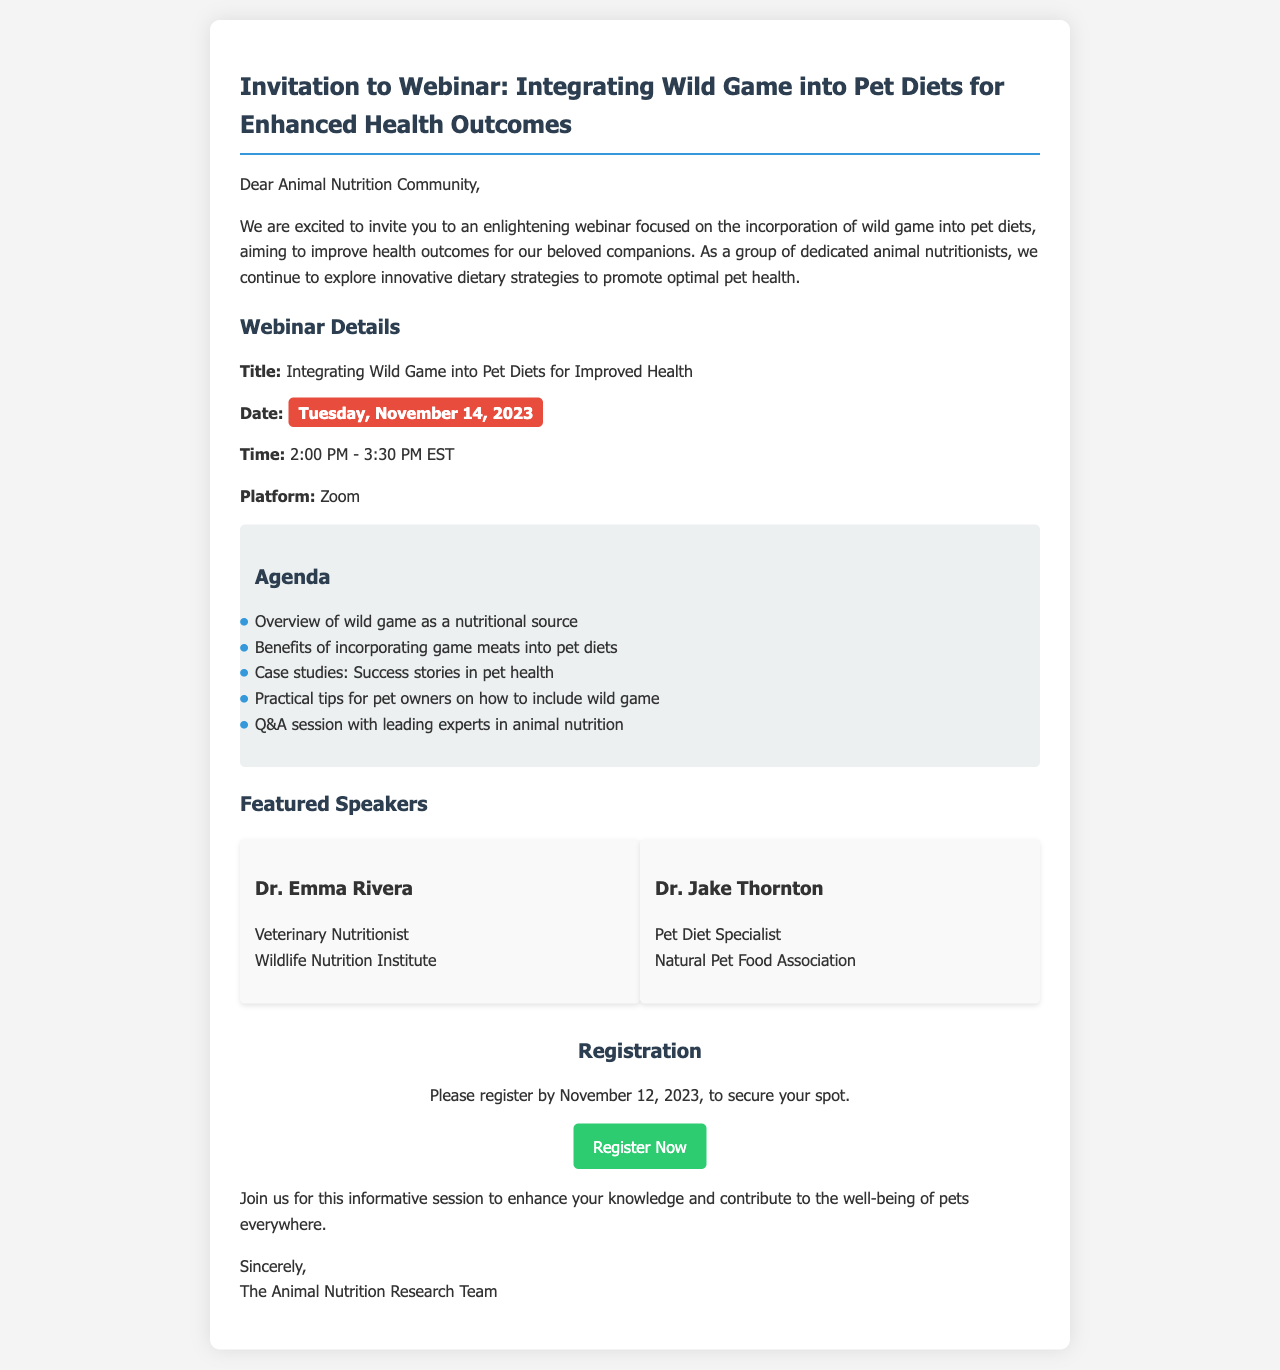What is the title of the webinar? The title of the webinar is explicitly mentioned in the document as "Integrating Wild Game into Pet Diets for Improved Health."
Answer: Integrating Wild Game into Pet Diets for Improved Health When is the webinar scheduled to take place? The date of the webinar is clearly stated in the document as "Tuesday, November 14, 2023."
Answer: Tuesday, November 14, 2023 What time does the webinar start? The starting time of the webinar is listed in the document as "2:00 PM - 3:30 PM EST."
Answer: 2:00 PM - 3:30 PM EST How many featured speakers are mentioned in the document? The document lists two featured speakers, Dr. Emma Rivera and Dr. Jake Thornton, under the "Featured Speakers" section.
Answer: 2 What platform will the webinar be held on? The platform for the webinar is identified in the details as "Zoom."
Answer: Zoom What is the registration deadline for the webinar? The document specifies that participants should register by "November 12, 2023."
Answer: November 12, 2023 Name one topic that will be covered in the agenda. The agenda section provides topics, one of which is "Overview of wild game as a nutritional source."
Answer: Overview of wild game as a nutritional source Who is Dr. Emma Rivera associated with? The document indicates that Dr. Emma Rivera is affiliated with the "Wildlife Nutrition Institute."
Answer: Wildlife Nutrition Institute What action is encouraged in the "Call to Action" section? The "Call to Action" section encourages readers to "Register Now" for the webinar.
Answer: Register Now 